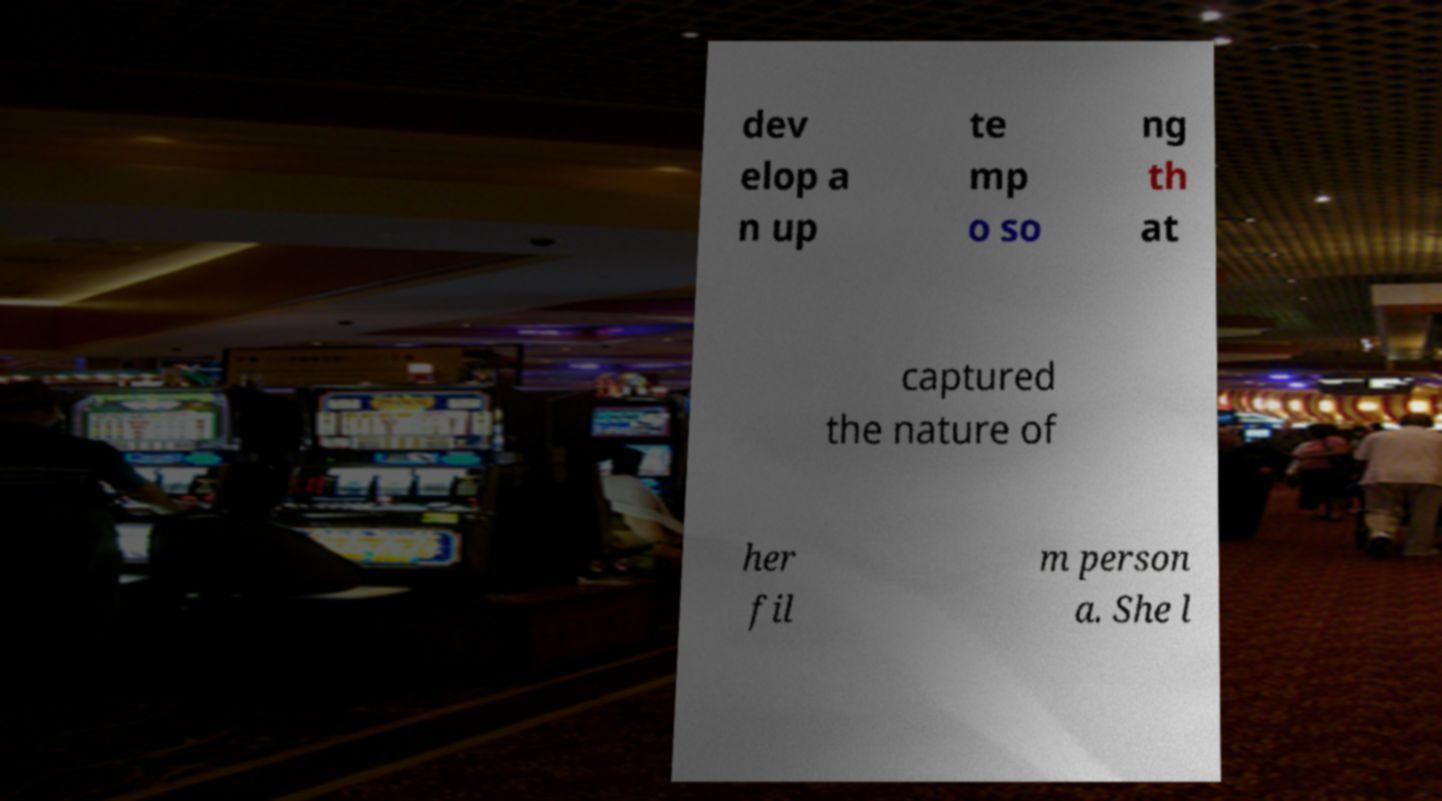I need the written content from this picture converted into text. Can you do that? dev elop a n up te mp o so ng th at captured the nature of her fil m person a. She l 